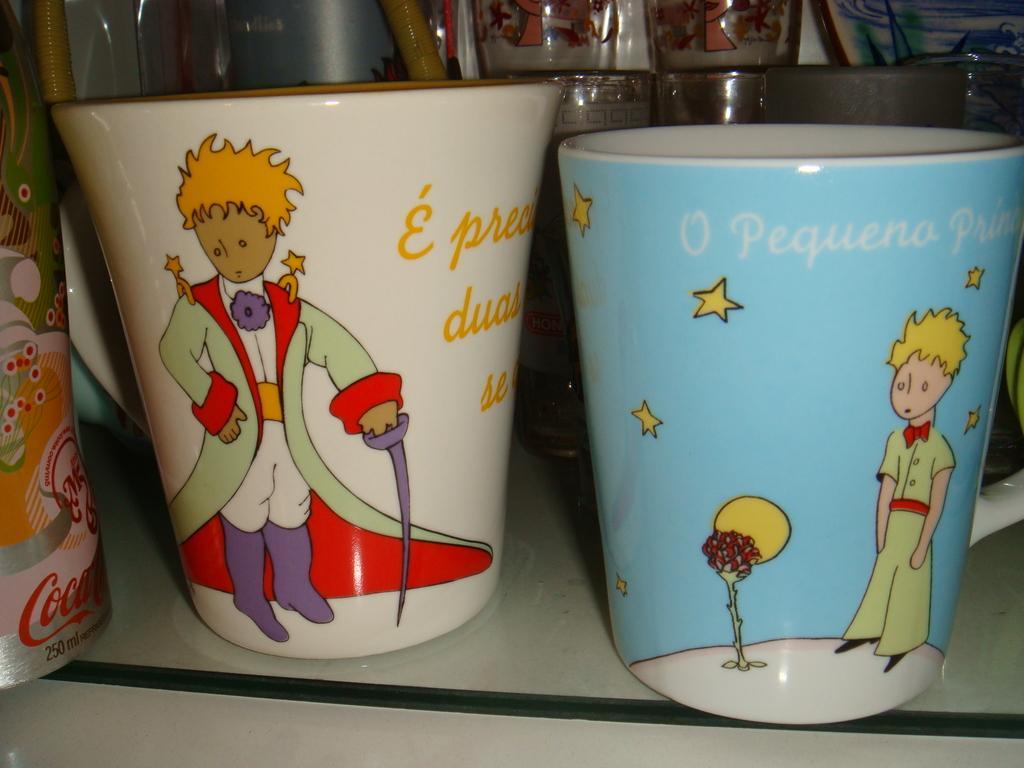Describe this image in one or two sentences. In this image we can see glass tumblers on the floor. 